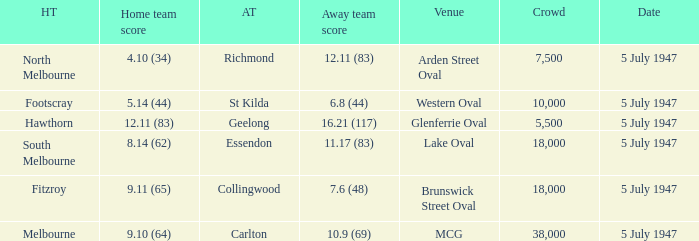Who was the away team when North Melbourne was the home team? Richmond. 